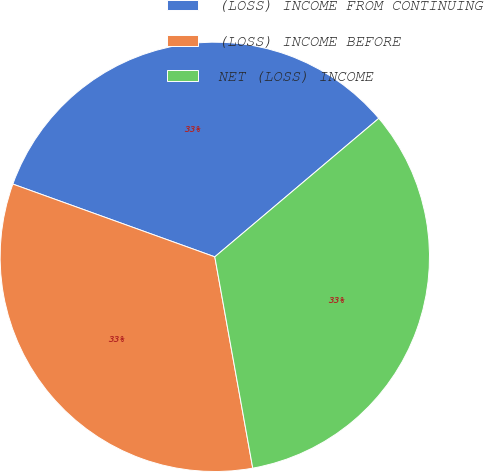<chart> <loc_0><loc_0><loc_500><loc_500><pie_chart><fcel>(LOSS) INCOME FROM CONTINUING<fcel>(LOSS) INCOME BEFORE<fcel>NET (LOSS) INCOME<nl><fcel>33.33%<fcel>33.33%<fcel>33.33%<nl></chart> 